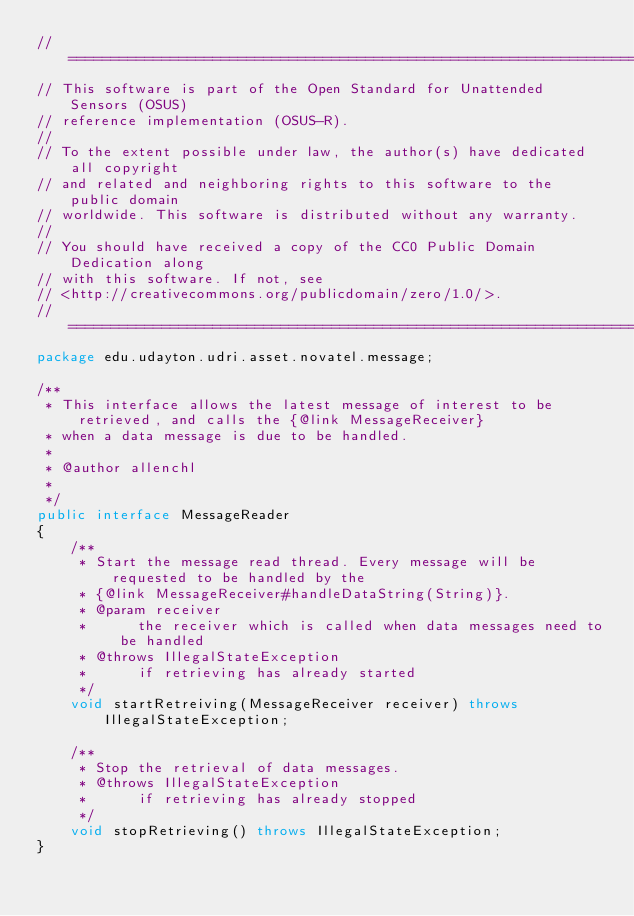Convert code to text. <code><loc_0><loc_0><loc_500><loc_500><_Java_>//==============================================================================
// This software is part of the Open Standard for Unattended Sensors (OSUS)
// reference implementation (OSUS-R).
//
// To the extent possible under law, the author(s) have dedicated all copyright
// and related and neighboring rights to this software to the public domain
// worldwide. This software is distributed without any warranty.
//
// You should have received a copy of the CC0 Public Domain Dedication along
// with this software. If not, see
// <http://creativecommons.org/publicdomain/zero/1.0/>.
//==============================================================================
package edu.udayton.udri.asset.novatel.message;

/**
 * This interface allows the latest message of interest to be retrieved, and calls the {@link MessageReceiver}
 * when a data message is due to be handled.
 * 
 * @author allenchl
 *
 */
public interface MessageReader
{
    /**
     * Start the message read thread. Every message will be requested to be handled by the 
     * {@link MessageReceiver#handleDataString(String)}.
     * @param receiver
     *      the receiver which is called when data messages need to be handled
     * @throws IllegalStateException
     *      if retrieving has already started
     */
    void startRetreiving(MessageReceiver receiver) throws IllegalStateException;
    
    /**
     * Stop the retrieval of data messages.
     * @throws IllegalStateException
     *      if retrieving has already stopped
     */
    void stopRetrieving() throws IllegalStateException;
}
</code> 